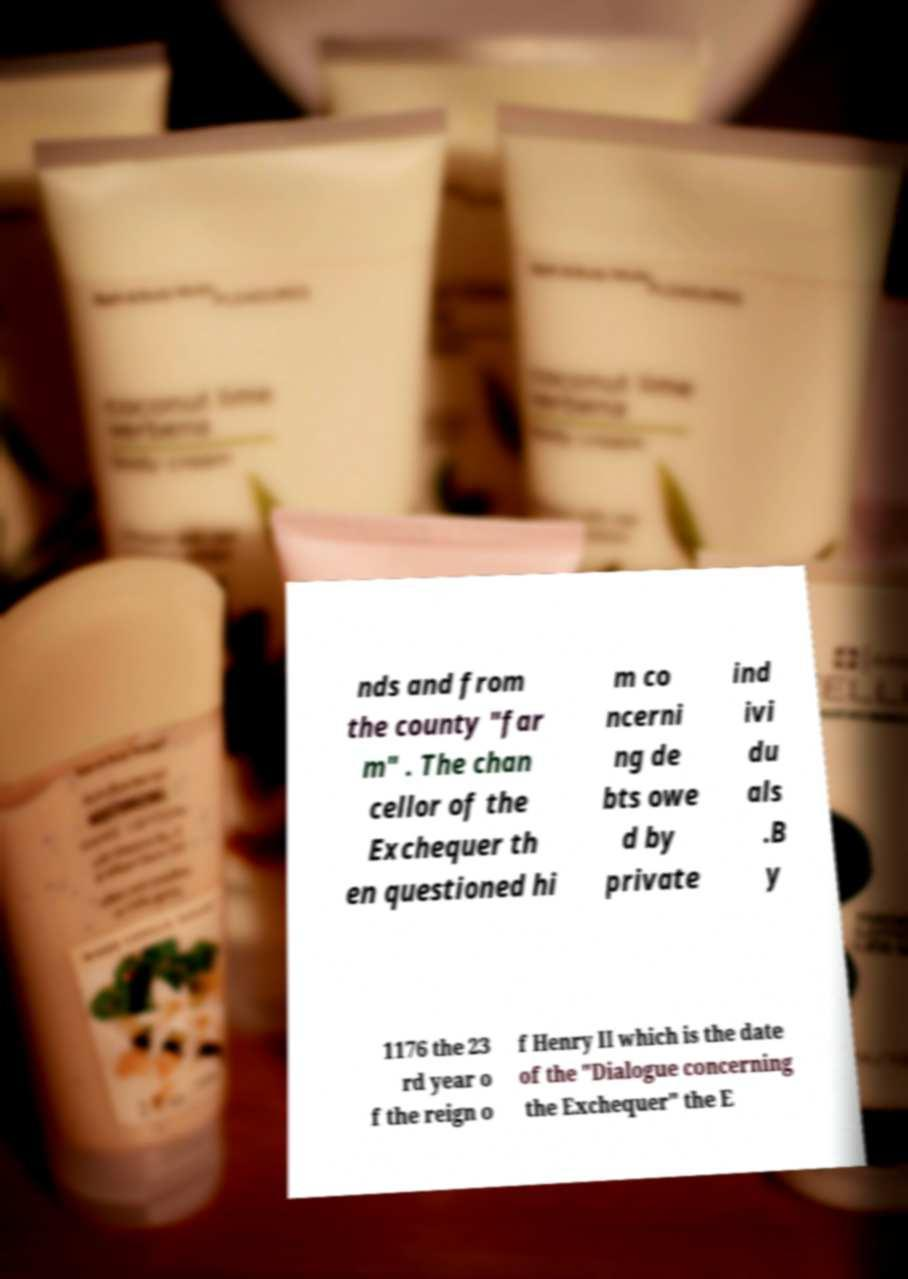Could you extract and type out the text from this image? nds and from the county "far m" . The chan cellor of the Exchequer th en questioned hi m co ncerni ng de bts owe d by private ind ivi du als .B y 1176 the 23 rd year o f the reign o f Henry II which is the date of the "Dialogue concerning the Exchequer" the E 